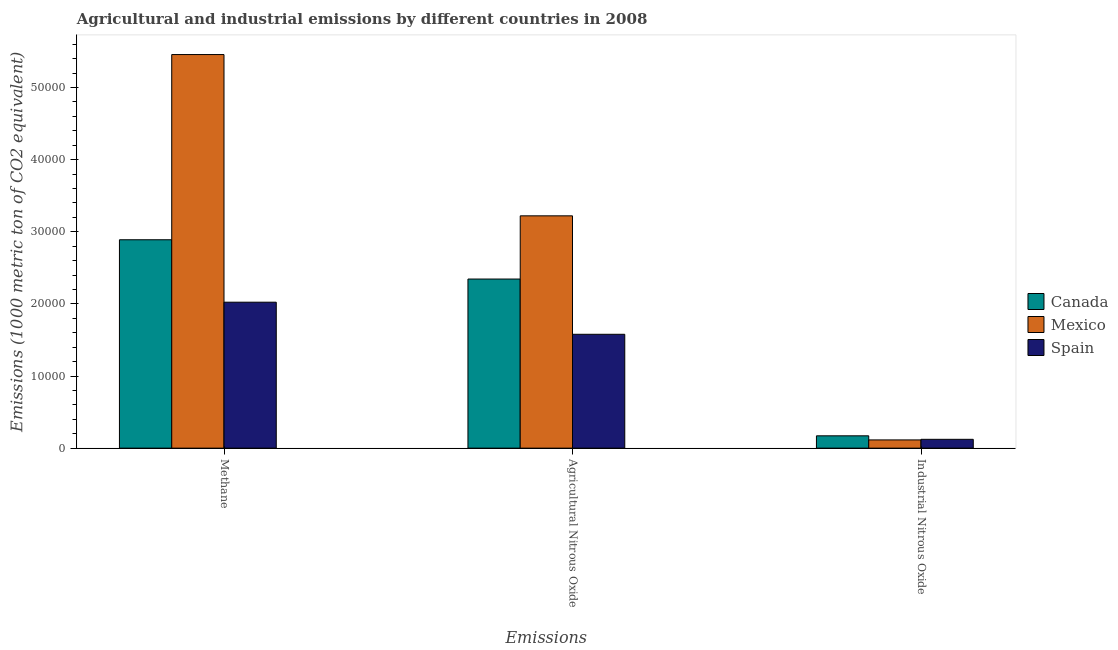Are the number of bars on each tick of the X-axis equal?
Your answer should be very brief. Yes. How many bars are there on the 2nd tick from the left?
Give a very brief answer. 3. How many bars are there on the 3rd tick from the right?
Give a very brief answer. 3. What is the label of the 3rd group of bars from the left?
Offer a terse response. Industrial Nitrous Oxide. What is the amount of industrial nitrous oxide emissions in Canada?
Provide a succinct answer. 1709.6. Across all countries, what is the maximum amount of industrial nitrous oxide emissions?
Provide a succinct answer. 1709.6. Across all countries, what is the minimum amount of methane emissions?
Offer a very short reply. 2.02e+04. In which country was the amount of industrial nitrous oxide emissions minimum?
Give a very brief answer. Mexico. What is the total amount of industrial nitrous oxide emissions in the graph?
Your answer should be very brief. 4075.6. What is the difference between the amount of industrial nitrous oxide emissions in Canada and that in Spain?
Give a very brief answer. 484.7. What is the difference between the amount of methane emissions in Mexico and the amount of industrial nitrous oxide emissions in Canada?
Provide a short and direct response. 5.29e+04. What is the average amount of agricultural nitrous oxide emissions per country?
Keep it short and to the point. 2.38e+04. What is the difference between the amount of methane emissions and amount of industrial nitrous oxide emissions in Mexico?
Offer a very short reply. 5.34e+04. In how many countries, is the amount of agricultural nitrous oxide emissions greater than 42000 metric ton?
Give a very brief answer. 0. What is the ratio of the amount of agricultural nitrous oxide emissions in Canada to that in Spain?
Provide a short and direct response. 1.49. Is the difference between the amount of agricultural nitrous oxide emissions in Mexico and Canada greater than the difference between the amount of methane emissions in Mexico and Canada?
Offer a terse response. No. What is the difference between the highest and the second highest amount of industrial nitrous oxide emissions?
Provide a short and direct response. 484.7. What is the difference between the highest and the lowest amount of industrial nitrous oxide emissions?
Give a very brief answer. 568.5. What does the 3rd bar from the left in Industrial Nitrous Oxide represents?
Your answer should be very brief. Spain. Is it the case that in every country, the sum of the amount of methane emissions and amount of agricultural nitrous oxide emissions is greater than the amount of industrial nitrous oxide emissions?
Give a very brief answer. Yes. How many bars are there?
Ensure brevity in your answer.  9. Are all the bars in the graph horizontal?
Your answer should be compact. No. Does the graph contain any zero values?
Your answer should be very brief. No. Does the graph contain grids?
Ensure brevity in your answer.  No. What is the title of the graph?
Ensure brevity in your answer.  Agricultural and industrial emissions by different countries in 2008. What is the label or title of the X-axis?
Your response must be concise. Emissions. What is the label or title of the Y-axis?
Keep it short and to the point. Emissions (1000 metric ton of CO2 equivalent). What is the Emissions (1000 metric ton of CO2 equivalent) in Canada in Methane?
Make the answer very short. 2.89e+04. What is the Emissions (1000 metric ton of CO2 equivalent) in Mexico in Methane?
Ensure brevity in your answer.  5.46e+04. What is the Emissions (1000 metric ton of CO2 equivalent) of Spain in Methane?
Provide a succinct answer. 2.02e+04. What is the Emissions (1000 metric ton of CO2 equivalent) in Canada in Agricultural Nitrous Oxide?
Keep it short and to the point. 2.34e+04. What is the Emissions (1000 metric ton of CO2 equivalent) of Mexico in Agricultural Nitrous Oxide?
Ensure brevity in your answer.  3.22e+04. What is the Emissions (1000 metric ton of CO2 equivalent) in Spain in Agricultural Nitrous Oxide?
Offer a terse response. 1.58e+04. What is the Emissions (1000 metric ton of CO2 equivalent) in Canada in Industrial Nitrous Oxide?
Make the answer very short. 1709.6. What is the Emissions (1000 metric ton of CO2 equivalent) of Mexico in Industrial Nitrous Oxide?
Keep it short and to the point. 1141.1. What is the Emissions (1000 metric ton of CO2 equivalent) of Spain in Industrial Nitrous Oxide?
Ensure brevity in your answer.  1224.9. Across all Emissions, what is the maximum Emissions (1000 metric ton of CO2 equivalent) in Canada?
Your answer should be compact. 2.89e+04. Across all Emissions, what is the maximum Emissions (1000 metric ton of CO2 equivalent) of Mexico?
Your answer should be very brief. 5.46e+04. Across all Emissions, what is the maximum Emissions (1000 metric ton of CO2 equivalent) in Spain?
Keep it short and to the point. 2.02e+04. Across all Emissions, what is the minimum Emissions (1000 metric ton of CO2 equivalent) in Canada?
Ensure brevity in your answer.  1709.6. Across all Emissions, what is the minimum Emissions (1000 metric ton of CO2 equivalent) in Mexico?
Give a very brief answer. 1141.1. Across all Emissions, what is the minimum Emissions (1000 metric ton of CO2 equivalent) in Spain?
Offer a very short reply. 1224.9. What is the total Emissions (1000 metric ton of CO2 equivalent) of Canada in the graph?
Offer a terse response. 5.41e+04. What is the total Emissions (1000 metric ton of CO2 equivalent) of Mexico in the graph?
Make the answer very short. 8.79e+04. What is the total Emissions (1000 metric ton of CO2 equivalent) in Spain in the graph?
Your answer should be very brief. 3.73e+04. What is the difference between the Emissions (1000 metric ton of CO2 equivalent) in Canada in Methane and that in Agricultural Nitrous Oxide?
Keep it short and to the point. 5448.3. What is the difference between the Emissions (1000 metric ton of CO2 equivalent) of Mexico in Methane and that in Agricultural Nitrous Oxide?
Provide a short and direct response. 2.24e+04. What is the difference between the Emissions (1000 metric ton of CO2 equivalent) of Spain in Methane and that in Agricultural Nitrous Oxide?
Provide a succinct answer. 4451.4. What is the difference between the Emissions (1000 metric ton of CO2 equivalent) in Canada in Methane and that in Industrial Nitrous Oxide?
Give a very brief answer. 2.72e+04. What is the difference between the Emissions (1000 metric ton of CO2 equivalent) of Mexico in Methane and that in Industrial Nitrous Oxide?
Your answer should be very brief. 5.34e+04. What is the difference between the Emissions (1000 metric ton of CO2 equivalent) in Spain in Methane and that in Industrial Nitrous Oxide?
Your answer should be compact. 1.90e+04. What is the difference between the Emissions (1000 metric ton of CO2 equivalent) of Canada in Agricultural Nitrous Oxide and that in Industrial Nitrous Oxide?
Offer a very short reply. 2.17e+04. What is the difference between the Emissions (1000 metric ton of CO2 equivalent) of Mexico in Agricultural Nitrous Oxide and that in Industrial Nitrous Oxide?
Your answer should be compact. 3.11e+04. What is the difference between the Emissions (1000 metric ton of CO2 equivalent) of Spain in Agricultural Nitrous Oxide and that in Industrial Nitrous Oxide?
Offer a terse response. 1.46e+04. What is the difference between the Emissions (1000 metric ton of CO2 equivalent) in Canada in Methane and the Emissions (1000 metric ton of CO2 equivalent) in Mexico in Agricultural Nitrous Oxide?
Offer a terse response. -3316.3. What is the difference between the Emissions (1000 metric ton of CO2 equivalent) of Canada in Methane and the Emissions (1000 metric ton of CO2 equivalent) of Spain in Agricultural Nitrous Oxide?
Offer a very short reply. 1.31e+04. What is the difference between the Emissions (1000 metric ton of CO2 equivalent) in Mexico in Methane and the Emissions (1000 metric ton of CO2 equivalent) in Spain in Agricultural Nitrous Oxide?
Give a very brief answer. 3.88e+04. What is the difference between the Emissions (1000 metric ton of CO2 equivalent) of Canada in Methane and the Emissions (1000 metric ton of CO2 equivalent) of Mexico in Industrial Nitrous Oxide?
Your response must be concise. 2.78e+04. What is the difference between the Emissions (1000 metric ton of CO2 equivalent) of Canada in Methane and the Emissions (1000 metric ton of CO2 equivalent) of Spain in Industrial Nitrous Oxide?
Your answer should be compact. 2.77e+04. What is the difference between the Emissions (1000 metric ton of CO2 equivalent) in Mexico in Methane and the Emissions (1000 metric ton of CO2 equivalent) in Spain in Industrial Nitrous Oxide?
Your response must be concise. 5.34e+04. What is the difference between the Emissions (1000 metric ton of CO2 equivalent) in Canada in Agricultural Nitrous Oxide and the Emissions (1000 metric ton of CO2 equivalent) in Mexico in Industrial Nitrous Oxide?
Offer a terse response. 2.23e+04. What is the difference between the Emissions (1000 metric ton of CO2 equivalent) of Canada in Agricultural Nitrous Oxide and the Emissions (1000 metric ton of CO2 equivalent) of Spain in Industrial Nitrous Oxide?
Ensure brevity in your answer.  2.22e+04. What is the difference between the Emissions (1000 metric ton of CO2 equivalent) in Mexico in Agricultural Nitrous Oxide and the Emissions (1000 metric ton of CO2 equivalent) in Spain in Industrial Nitrous Oxide?
Offer a terse response. 3.10e+04. What is the average Emissions (1000 metric ton of CO2 equivalent) of Canada per Emissions?
Offer a very short reply. 1.80e+04. What is the average Emissions (1000 metric ton of CO2 equivalent) of Mexico per Emissions?
Offer a very short reply. 2.93e+04. What is the average Emissions (1000 metric ton of CO2 equivalent) of Spain per Emissions?
Ensure brevity in your answer.  1.24e+04. What is the difference between the Emissions (1000 metric ton of CO2 equivalent) in Canada and Emissions (1000 metric ton of CO2 equivalent) in Mexico in Methane?
Make the answer very short. -2.57e+04. What is the difference between the Emissions (1000 metric ton of CO2 equivalent) in Canada and Emissions (1000 metric ton of CO2 equivalent) in Spain in Methane?
Give a very brief answer. 8658.1. What is the difference between the Emissions (1000 metric ton of CO2 equivalent) of Mexico and Emissions (1000 metric ton of CO2 equivalent) of Spain in Methane?
Offer a very short reply. 3.43e+04. What is the difference between the Emissions (1000 metric ton of CO2 equivalent) of Canada and Emissions (1000 metric ton of CO2 equivalent) of Mexico in Agricultural Nitrous Oxide?
Ensure brevity in your answer.  -8764.6. What is the difference between the Emissions (1000 metric ton of CO2 equivalent) in Canada and Emissions (1000 metric ton of CO2 equivalent) in Spain in Agricultural Nitrous Oxide?
Give a very brief answer. 7661.2. What is the difference between the Emissions (1000 metric ton of CO2 equivalent) of Mexico and Emissions (1000 metric ton of CO2 equivalent) of Spain in Agricultural Nitrous Oxide?
Provide a short and direct response. 1.64e+04. What is the difference between the Emissions (1000 metric ton of CO2 equivalent) of Canada and Emissions (1000 metric ton of CO2 equivalent) of Mexico in Industrial Nitrous Oxide?
Give a very brief answer. 568.5. What is the difference between the Emissions (1000 metric ton of CO2 equivalent) of Canada and Emissions (1000 metric ton of CO2 equivalent) of Spain in Industrial Nitrous Oxide?
Keep it short and to the point. 484.7. What is the difference between the Emissions (1000 metric ton of CO2 equivalent) in Mexico and Emissions (1000 metric ton of CO2 equivalent) in Spain in Industrial Nitrous Oxide?
Your response must be concise. -83.8. What is the ratio of the Emissions (1000 metric ton of CO2 equivalent) in Canada in Methane to that in Agricultural Nitrous Oxide?
Your answer should be very brief. 1.23. What is the ratio of the Emissions (1000 metric ton of CO2 equivalent) of Mexico in Methane to that in Agricultural Nitrous Oxide?
Your answer should be very brief. 1.69. What is the ratio of the Emissions (1000 metric ton of CO2 equivalent) of Spain in Methane to that in Agricultural Nitrous Oxide?
Offer a very short reply. 1.28. What is the ratio of the Emissions (1000 metric ton of CO2 equivalent) in Canada in Methane to that in Industrial Nitrous Oxide?
Your answer should be very brief. 16.9. What is the ratio of the Emissions (1000 metric ton of CO2 equivalent) of Mexico in Methane to that in Industrial Nitrous Oxide?
Give a very brief answer. 47.83. What is the ratio of the Emissions (1000 metric ton of CO2 equivalent) of Spain in Methane to that in Industrial Nitrous Oxide?
Your response must be concise. 16.52. What is the ratio of the Emissions (1000 metric ton of CO2 equivalent) in Canada in Agricultural Nitrous Oxide to that in Industrial Nitrous Oxide?
Provide a succinct answer. 13.72. What is the ratio of the Emissions (1000 metric ton of CO2 equivalent) of Mexico in Agricultural Nitrous Oxide to that in Industrial Nitrous Oxide?
Your answer should be very brief. 28.23. What is the ratio of the Emissions (1000 metric ton of CO2 equivalent) in Spain in Agricultural Nitrous Oxide to that in Industrial Nitrous Oxide?
Your response must be concise. 12.89. What is the difference between the highest and the second highest Emissions (1000 metric ton of CO2 equivalent) in Canada?
Provide a succinct answer. 5448.3. What is the difference between the highest and the second highest Emissions (1000 metric ton of CO2 equivalent) of Mexico?
Offer a very short reply. 2.24e+04. What is the difference between the highest and the second highest Emissions (1000 metric ton of CO2 equivalent) of Spain?
Keep it short and to the point. 4451.4. What is the difference between the highest and the lowest Emissions (1000 metric ton of CO2 equivalent) of Canada?
Provide a short and direct response. 2.72e+04. What is the difference between the highest and the lowest Emissions (1000 metric ton of CO2 equivalent) of Mexico?
Your answer should be very brief. 5.34e+04. What is the difference between the highest and the lowest Emissions (1000 metric ton of CO2 equivalent) of Spain?
Keep it short and to the point. 1.90e+04. 